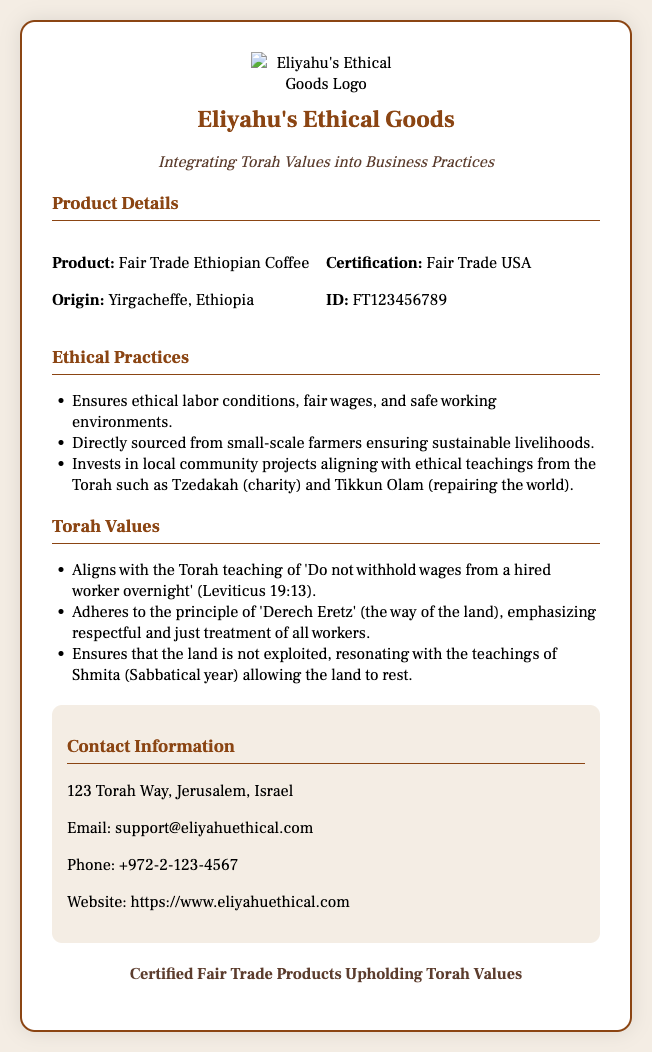What is the product? The product is listed directly under "Product Details" in the document.
Answer: Fair Trade Ethiopian Coffee Where is the product sourced from? The origin of the product is detailed in the same section as the product name.
Answer: Yirgacheffe, Ethiopia What certification does the product have? The certification is specifically mentioned in the "Product Details" section.
Answer: Fair Trade USA What ID is associated with the product? The ID is provided alongside certification in the document.
Answer: FT123456789 What ethical practice involves investing in local community projects? The document explains this initiative under "Ethical Practices" and links it to Torah concepts.
Answer: Tzedakah and Tikkun Olam Which Torah teaching advises against withholding wages? The document cites this teaching in the "Torah Values" section.
Answer: Leviticus 19:13 What principle emphasizes the respectful treatment of workers? This principle is highlighted in the Torah Values section of the document.
Answer: Derech Eretz What is the contact email provided? The contact email can be found in the "Contact Information" section.
Answer: support@eliyahuethical.com What physical address is listed for Eliyahu's Ethical Goods? The address is indicated in the same section dedicated to contact information.
Answer: 123 Torah Way, Jerusalem, Israel 